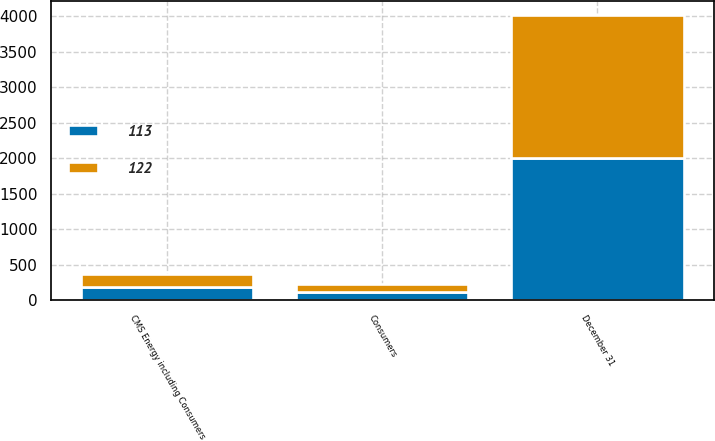<chart> <loc_0><loc_0><loc_500><loc_500><stacked_bar_chart><ecel><fcel>December 31<fcel>CMS Energy including Consumers<fcel>Consumers<nl><fcel>122<fcel>2010<fcel>187<fcel>113<nl><fcel>113<fcel>2009<fcel>183<fcel>122<nl></chart> 